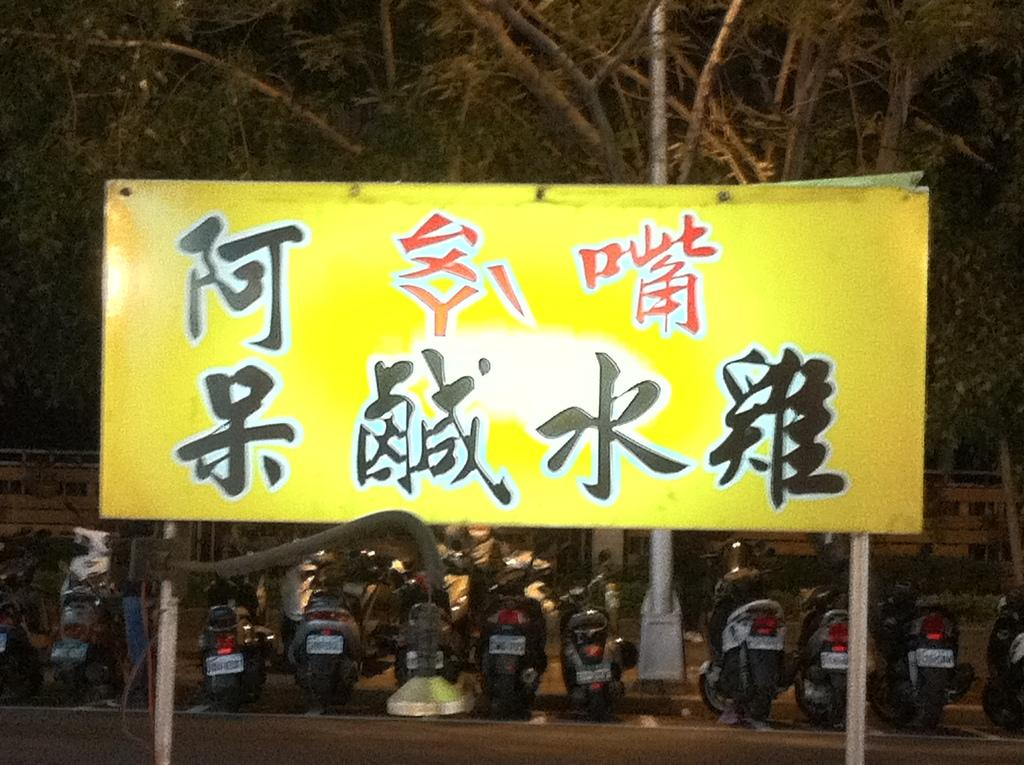What is the main object in the foreground of the image? There is a yellow colored board in the foreground of the image. What can be seen in the background of the image? There are motorbikes on the road, a pole, trees, and a railing-like object in the background of the image. How would you describe the sky in the image? The sky is dark in the background of the image. Can you see any cracks on the road where the motorbikes are riding in the image? There is no mention of cracks on the road in the provided facts, so it cannot be determined from the image. How many hens are visible in the image? There are no hens present in the image. 